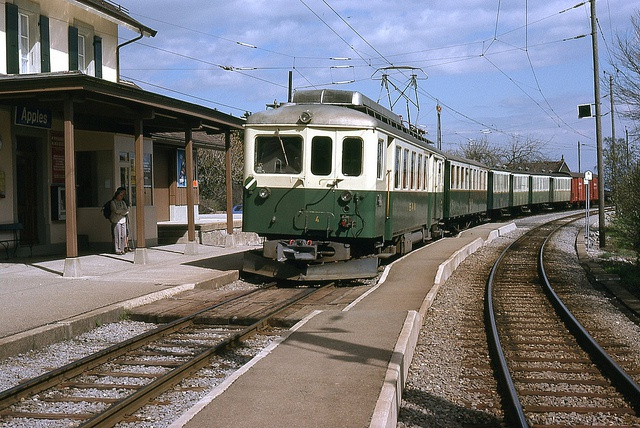Describe the objects in this image and their specific colors. I can see train in gray, black, white, and darkgreen tones, people in gray, black, and darkgray tones, bench in gray and black tones, people in gray and black tones, and backpack in gray and black tones in this image. 